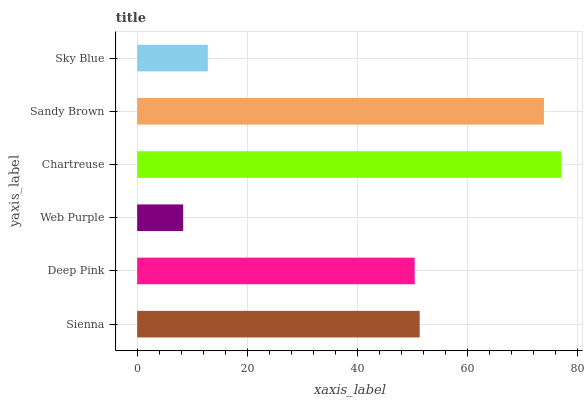Is Web Purple the minimum?
Answer yes or no. Yes. Is Chartreuse the maximum?
Answer yes or no. Yes. Is Deep Pink the minimum?
Answer yes or no. No. Is Deep Pink the maximum?
Answer yes or no. No. Is Sienna greater than Deep Pink?
Answer yes or no. Yes. Is Deep Pink less than Sienna?
Answer yes or no. Yes. Is Deep Pink greater than Sienna?
Answer yes or no. No. Is Sienna less than Deep Pink?
Answer yes or no. No. Is Sienna the high median?
Answer yes or no. Yes. Is Deep Pink the low median?
Answer yes or no. Yes. Is Sky Blue the high median?
Answer yes or no. No. Is Chartreuse the low median?
Answer yes or no. No. 